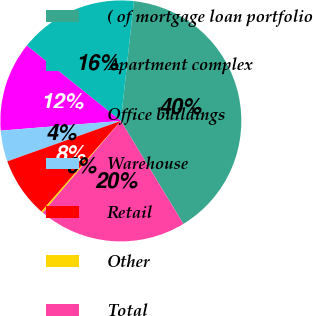<chart> <loc_0><loc_0><loc_500><loc_500><pie_chart><fcel>( of mortgage loan portfolio<fcel>Apartment complex<fcel>Office buildings<fcel>Warehouse<fcel>Retail<fcel>Other<fcel>Total<nl><fcel>39.59%<fcel>15.97%<fcel>12.04%<fcel>4.16%<fcel>8.1%<fcel>0.23%<fcel>19.91%<nl></chart> 